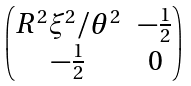<formula> <loc_0><loc_0><loc_500><loc_500>\begin{pmatrix} R ^ { 2 } \xi ^ { 2 } / \theta ^ { 2 } & - \frac { 1 } { 2 } \\ - \frac { 1 } { 2 } & 0 \end{pmatrix}</formula> 